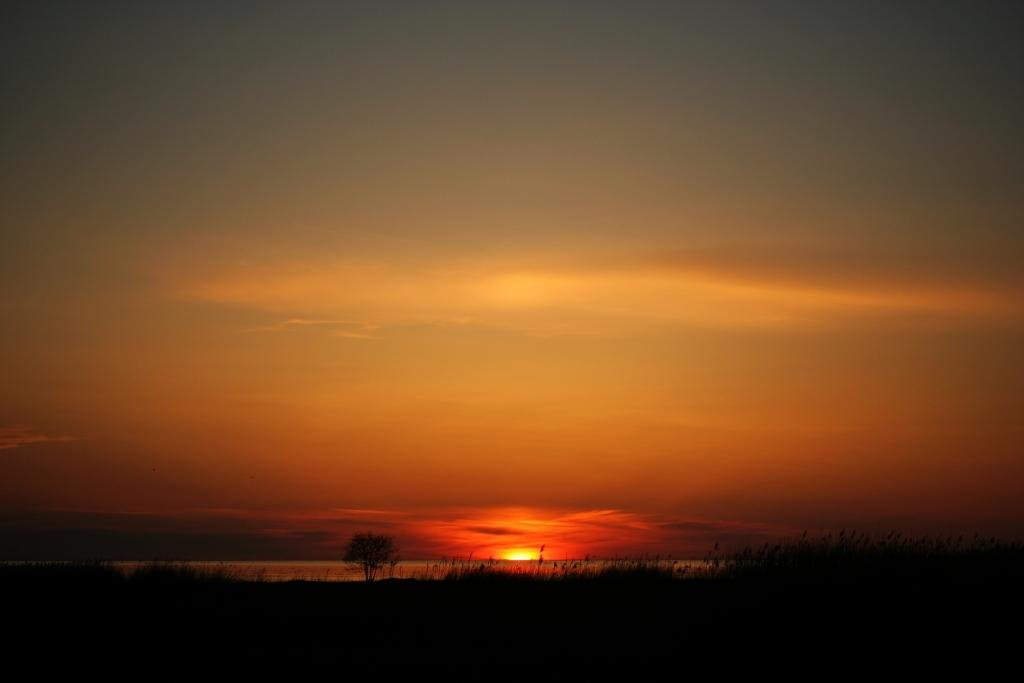What type of vegetation can be seen in the image? There are trees in the image. What part of the natural environment is visible in the image? The sky is visible in the background of the image. What type of comfort can be found in the key that is present in the image? There is no key present in the image, so it is not possible to determine what type of comfort it might provide. 